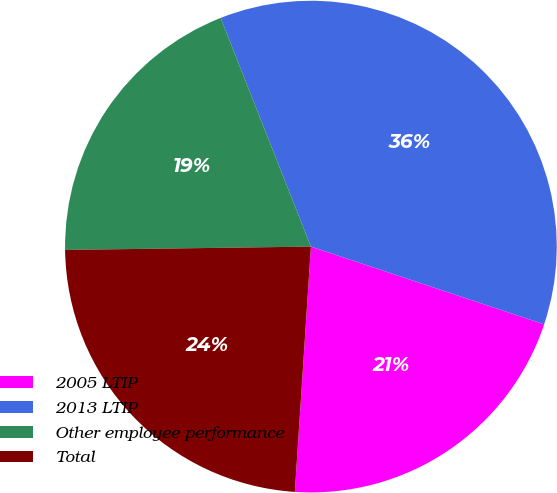Convert chart. <chart><loc_0><loc_0><loc_500><loc_500><pie_chart><fcel>2005 LTIP<fcel>2013 LTIP<fcel>Other employee performance<fcel>Total<nl><fcel>20.92%<fcel>36.1%<fcel>19.23%<fcel>23.74%<nl></chart> 